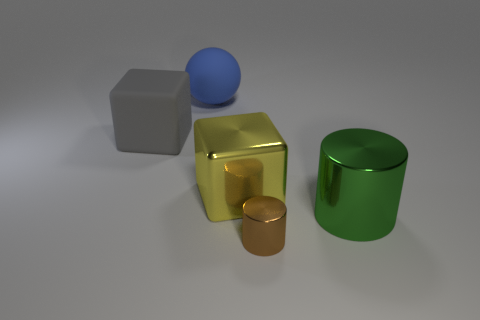Add 2 tiny brown matte cylinders. How many objects exist? 7 Subtract all spheres. How many objects are left? 4 Add 4 big yellow things. How many big yellow things are left? 5 Add 4 small brown cylinders. How many small brown cylinders exist? 5 Subtract 0 green spheres. How many objects are left? 5 Subtract all large gray objects. Subtract all blue matte objects. How many objects are left? 3 